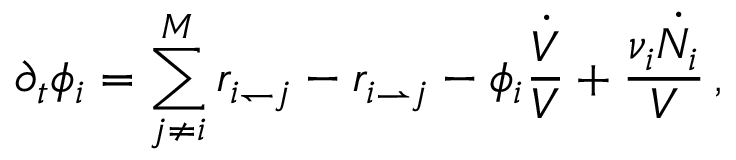Convert formula to latex. <formula><loc_0><loc_0><loc_500><loc_500>\partial _ { t } \phi _ { i } = \sum _ { j \neq i } ^ { M } r _ { i \leftharpoondown j } - r _ { i \rightharpoonup j } - \phi _ { i } \frac { \dot { V } } { V } + \frac { \nu _ { i } \dot { N _ { i } } } { V } \, ,</formula> 